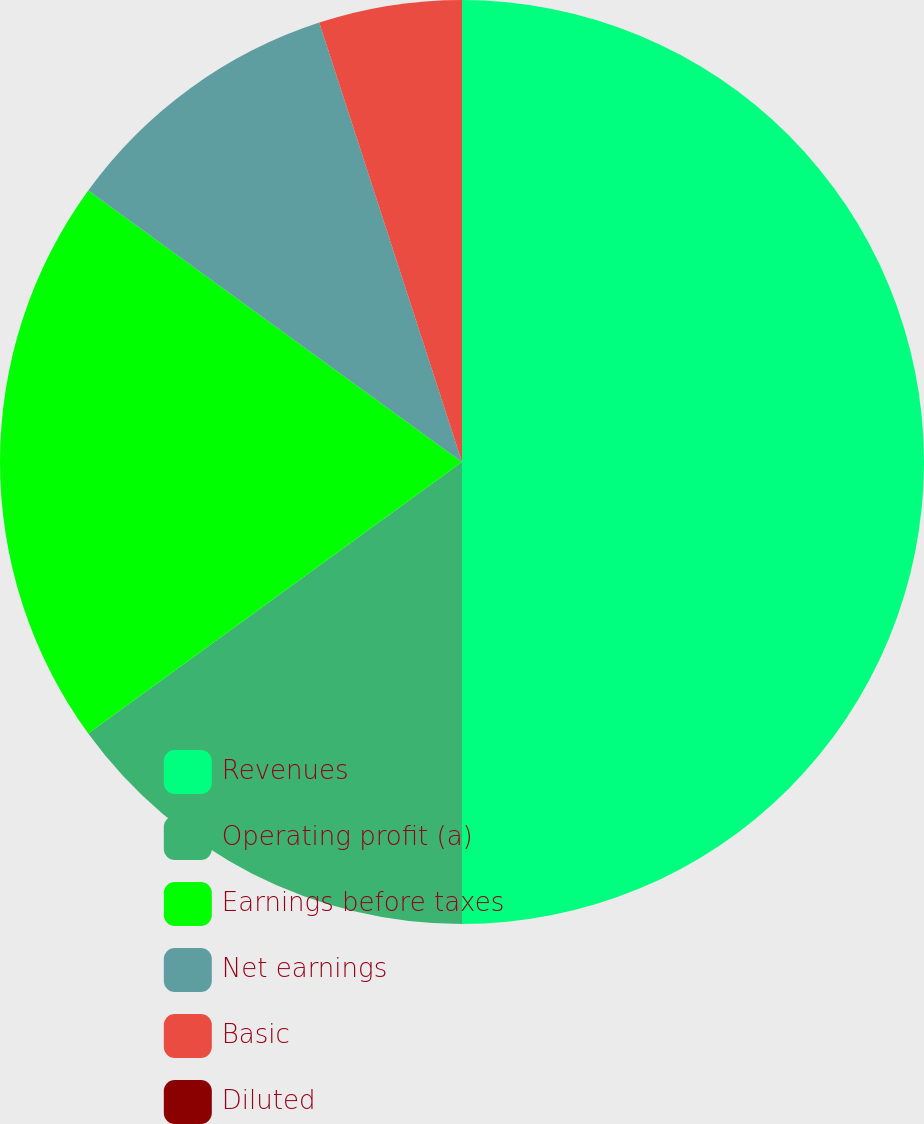Convert chart. <chart><loc_0><loc_0><loc_500><loc_500><pie_chart><fcel>Revenues<fcel>Operating profit (a)<fcel>Earnings before taxes<fcel>Net earnings<fcel>Basic<fcel>Diluted<nl><fcel>50.0%<fcel>15.0%<fcel>20.0%<fcel>10.0%<fcel>5.0%<fcel>0.0%<nl></chart> 